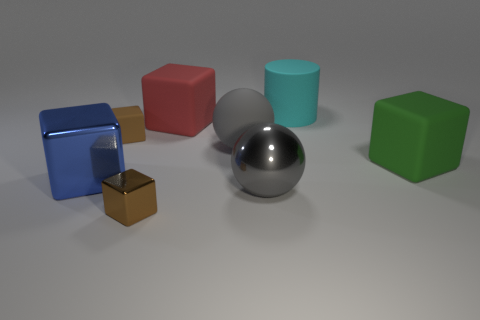Is the shape of the gray thing that is left of the gray metal object the same as  the large red thing?
Ensure brevity in your answer.  No. What is the material of the other large thing that is the same shape as the gray matte thing?
Ensure brevity in your answer.  Metal. How many gray matte objects have the same size as the green thing?
Offer a terse response. 1. What color is the object that is behind the rubber ball and to the right of the big red matte thing?
Keep it short and to the point. Cyan. Is the number of gray objects less than the number of large rubber things?
Provide a succinct answer. Yes. There is a tiny matte object; is its color the same as the small block that is in front of the small rubber object?
Offer a terse response. Yes. Are there the same number of tiny brown matte cubes on the left side of the big cyan rubber cylinder and objects on the right side of the large green thing?
Your response must be concise. No. What number of other small matte things have the same shape as the small matte object?
Make the answer very short. 0. Are any metal cylinders visible?
Ensure brevity in your answer.  No. Is the material of the green cube the same as the big gray ball in front of the big gray rubber sphere?
Provide a short and direct response. No. 